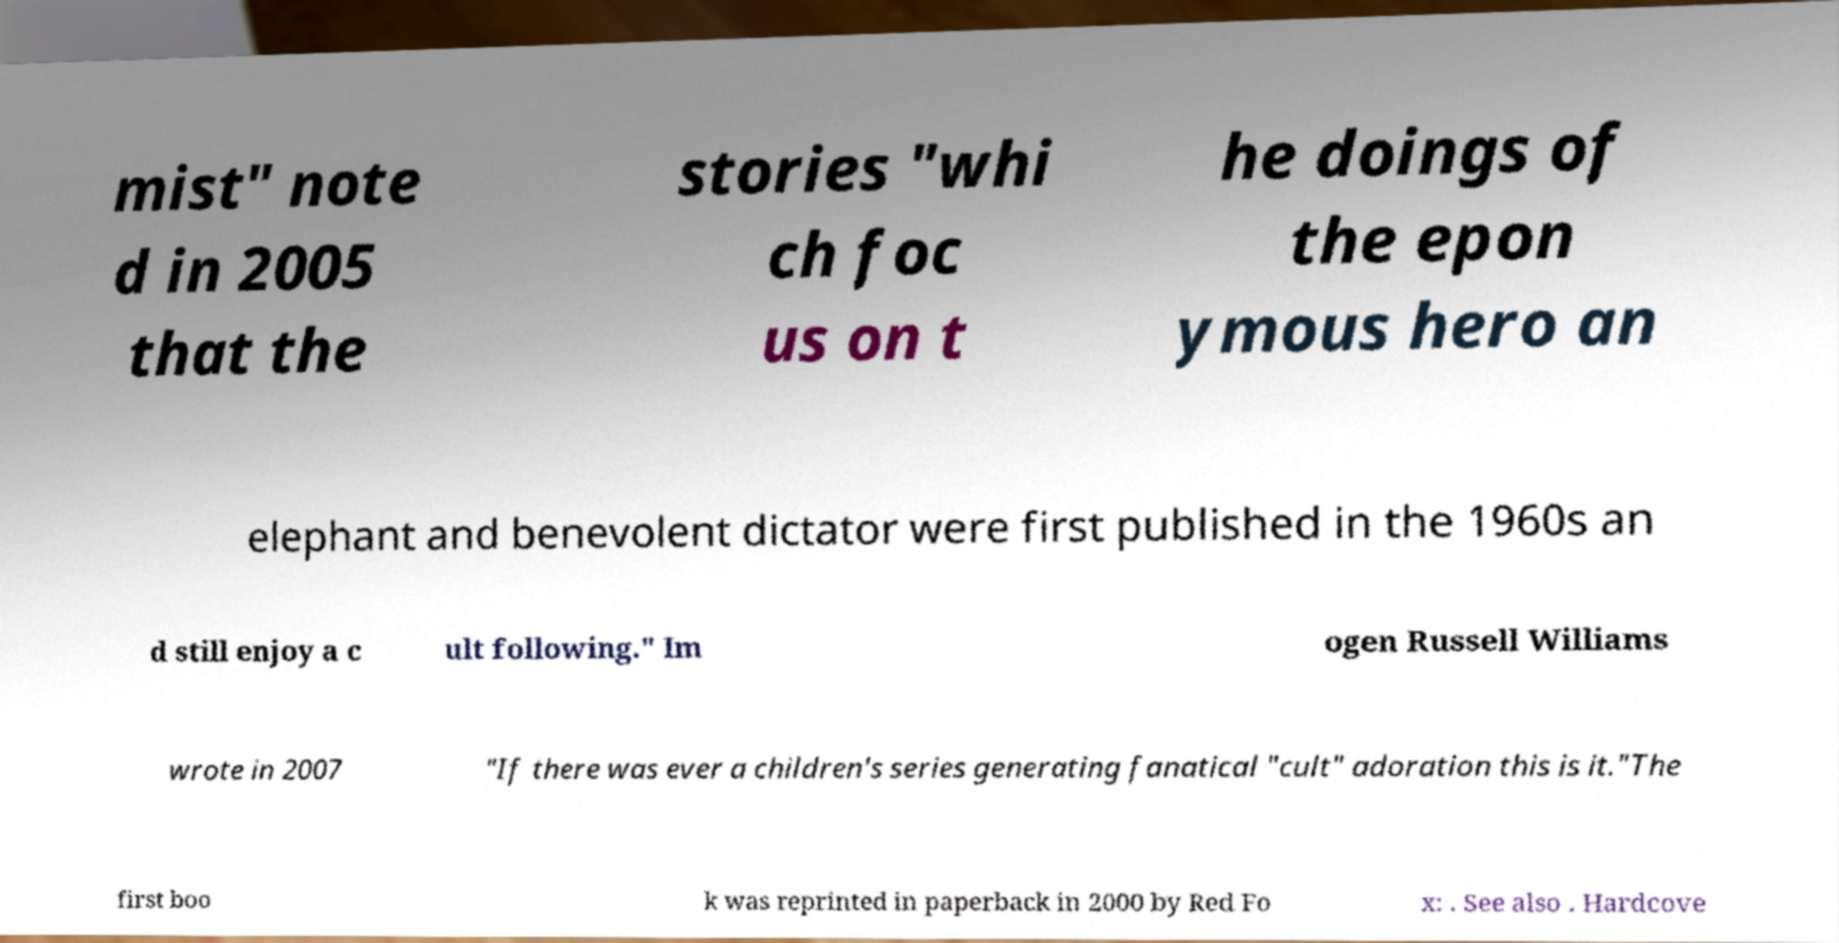Can you accurately transcribe the text from the provided image for me? mist" note d in 2005 that the stories "whi ch foc us on t he doings of the epon ymous hero an elephant and benevolent dictator were first published in the 1960s an d still enjoy a c ult following." Im ogen Russell Williams wrote in 2007 "If there was ever a children's series generating fanatical "cult" adoration this is it."The first boo k was reprinted in paperback in 2000 by Red Fo x: . See also . Hardcove 